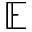Convert formula to latex. <formula><loc_0><loc_0><loc_500><loc_500>\mathbb { E }</formula> 